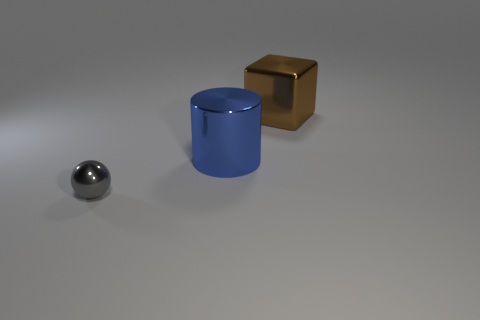Is there any other thing that is the same size as the shiny ball?
Provide a short and direct response. No. What size is the brown object that is made of the same material as the small gray thing?
Make the answer very short. Large. Is the blue metal object the same size as the metal cube?
Give a very brief answer. Yes. Is there a brown object?
Provide a short and direct response. Yes. What is the size of the object to the left of the big thing that is left of the shiny thing that is to the right of the blue object?
Your answer should be very brief. Small. What number of other gray cubes have the same material as the large cube?
Give a very brief answer. 0. What number of brown objects have the same size as the gray ball?
Offer a terse response. 0. What is the small thing in front of the large shiny thing that is left of the large shiny thing behind the blue metallic cylinder made of?
Your response must be concise. Metal. What number of things are big cubes or big things?
Provide a succinct answer. 2. Are there any other things that have the same material as the brown block?
Your answer should be very brief. Yes. 